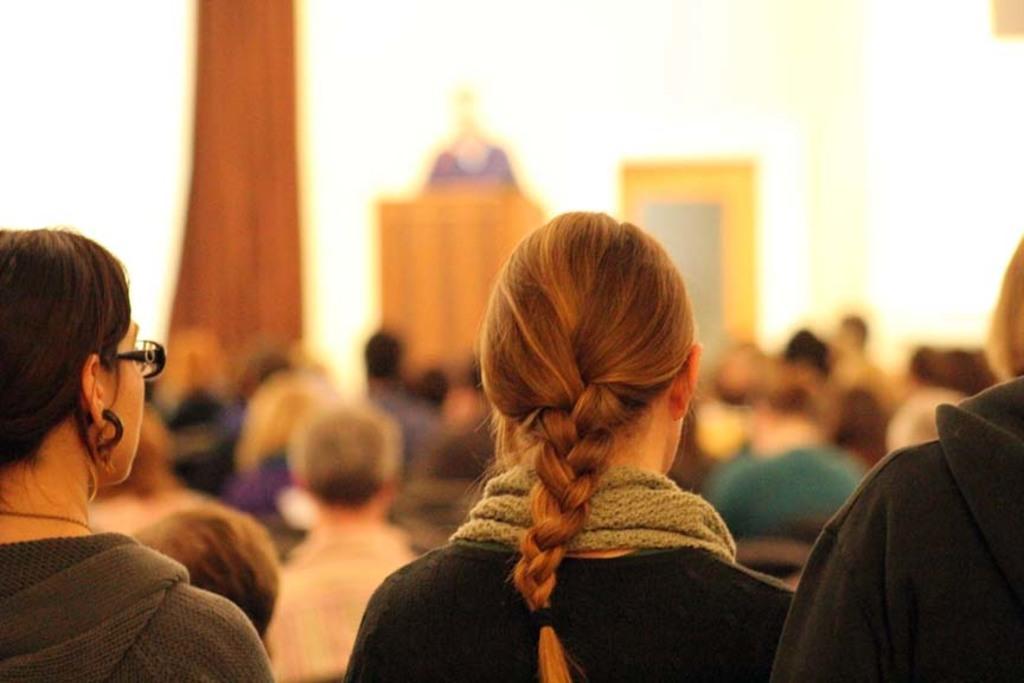Could you give a brief overview of what you see in this image? As we can see in the image there are group of people here and there. In the background there is a white color wall and a door. The background is little blurred. 